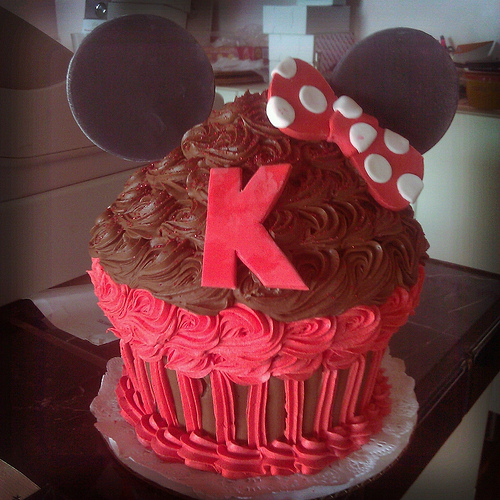<image>
Can you confirm if the letter k is on the cake? Yes. Looking at the image, I can see the letter k is positioned on top of the cake, with the cake providing support. 